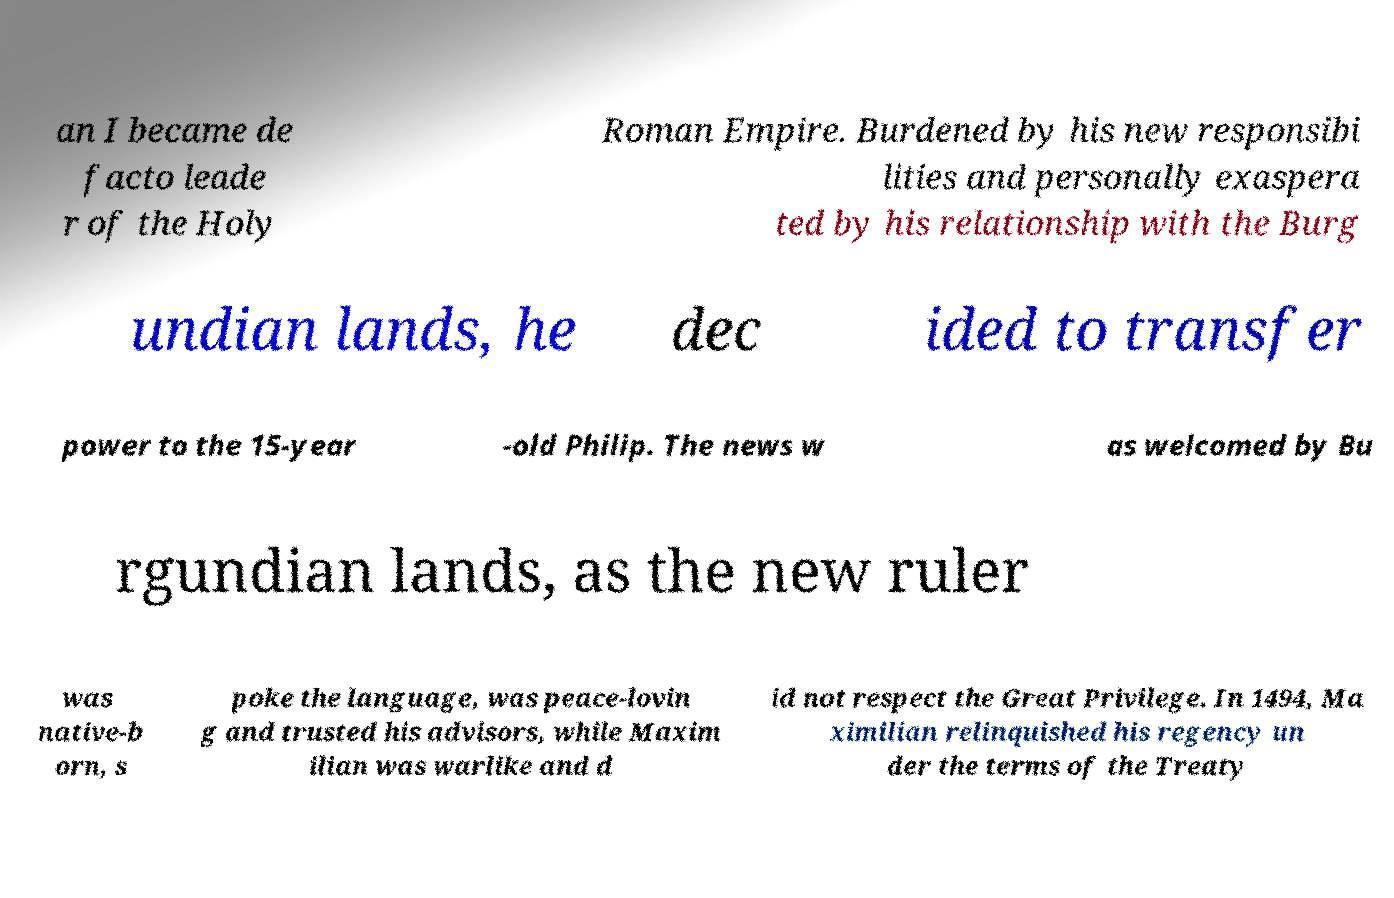Could you assist in decoding the text presented in this image and type it out clearly? an I became de facto leade r of the Holy Roman Empire. Burdened by his new responsibi lities and personally exaspera ted by his relationship with the Burg undian lands, he dec ided to transfer power to the 15-year -old Philip. The news w as welcomed by Bu rgundian lands, as the new ruler was native-b orn, s poke the language, was peace-lovin g and trusted his advisors, while Maxim ilian was warlike and d id not respect the Great Privilege. In 1494, Ma ximilian relinquished his regency un der the terms of the Treaty 